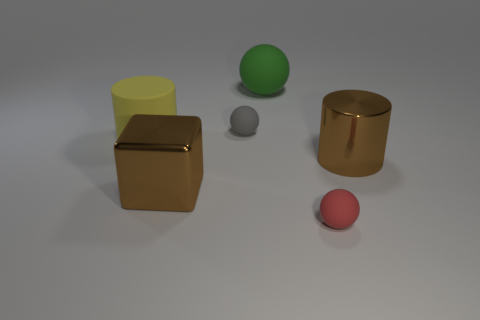Is the large metal block the same color as the shiny cylinder?
Ensure brevity in your answer.  Yes. There is a cylinder that is the same color as the metallic cube; what size is it?
Your answer should be very brief. Large. Is there a metal cylinder that has the same color as the big metallic cube?
Ensure brevity in your answer.  Yes. How many red things have the same shape as the yellow object?
Your answer should be very brief. 0. There is a big brown metal thing that is in front of the big cylinder to the right of the big yellow thing that is to the left of the gray thing; what is its shape?
Offer a very short reply. Cube. What material is the large object that is in front of the yellow rubber cylinder and on the left side of the red object?
Offer a very short reply. Metal. Does the brown shiny thing on the left side of the red rubber thing have the same size as the tiny red ball?
Provide a short and direct response. No. Is the number of balls on the left side of the big ball greater than the number of red things that are left of the big block?
Your response must be concise. Yes. What color is the cylinder that is behind the metallic object that is to the right of the matte object that is in front of the yellow matte thing?
Keep it short and to the point. Yellow. Does the big shiny thing left of the big green object have the same color as the metal cylinder?
Offer a terse response. Yes. 